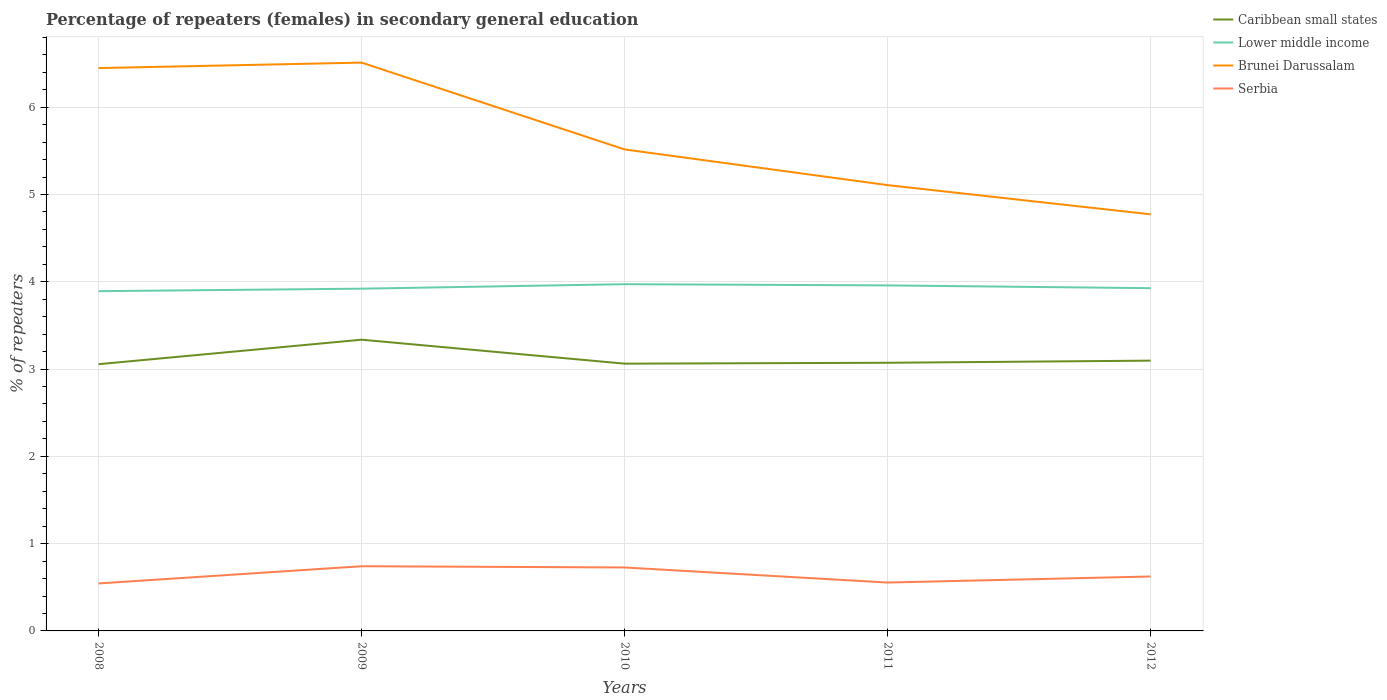How many different coloured lines are there?
Provide a succinct answer. 4. Does the line corresponding to Caribbean small states intersect with the line corresponding to Serbia?
Offer a terse response. No. Is the number of lines equal to the number of legend labels?
Offer a terse response. Yes. Across all years, what is the maximum percentage of female repeaters in Brunei Darussalam?
Provide a short and direct response. 4.77. What is the total percentage of female repeaters in Serbia in the graph?
Provide a short and direct response. 0.19. What is the difference between the highest and the second highest percentage of female repeaters in Serbia?
Provide a succinct answer. 0.2. What is the difference between the highest and the lowest percentage of female repeaters in Lower middle income?
Provide a short and direct response. 2. Is the percentage of female repeaters in Caribbean small states strictly greater than the percentage of female repeaters in Serbia over the years?
Offer a very short reply. No. How many lines are there?
Offer a very short reply. 4. How many years are there in the graph?
Offer a terse response. 5. Are the values on the major ticks of Y-axis written in scientific E-notation?
Give a very brief answer. No. Does the graph contain any zero values?
Offer a terse response. No. How are the legend labels stacked?
Make the answer very short. Vertical. What is the title of the graph?
Offer a very short reply. Percentage of repeaters (females) in secondary general education. What is the label or title of the Y-axis?
Provide a short and direct response. % of repeaters. What is the % of repeaters in Caribbean small states in 2008?
Offer a terse response. 3.06. What is the % of repeaters in Lower middle income in 2008?
Offer a terse response. 3.89. What is the % of repeaters in Brunei Darussalam in 2008?
Offer a terse response. 6.45. What is the % of repeaters of Serbia in 2008?
Offer a terse response. 0.54. What is the % of repeaters of Caribbean small states in 2009?
Offer a terse response. 3.34. What is the % of repeaters in Lower middle income in 2009?
Your answer should be compact. 3.92. What is the % of repeaters of Brunei Darussalam in 2009?
Provide a succinct answer. 6.51. What is the % of repeaters in Serbia in 2009?
Your answer should be very brief. 0.74. What is the % of repeaters of Caribbean small states in 2010?
Provide a succinct answer. 3.06. What is the % of repeaters of Lower middle income in 2010?
Offer a very short reply. 3.97. What is the % of repeaters of Brunei Darussalam in 2010?
Your answer should be compact. 5.52. What is the % of repeaters in Serbia in 2010?
Provide a succinct answer. 0.73. What is the % of repeaters of Caribbean small states in 2011?
Your answer should be very brief. 3.07. What is the % of repeaters of Lower middle income in 2011?
Your answer should be compact. 3.96. What is the % of repeaters of Brunei Darussalam in 2011?
Your response must be concise. 5.11. What is the % of repeaters of Serbia in 2011?
Keep it short and to the point. 0.55. What is the % of repeaters in Caribbean small states in 2012?
Provide a short and direct response. 3.1. What is the % of repeaters of Lower middle income in 2012?
Make the answer very short. 3.93. What is the % of repeaters of Brunei Darussalam in 2012?
Offer a very short reply. 4.77. What is the % of repeaters of Serbia in 2012?
Keep it short and to the point. 0.62. Across all years, what is the maximum % of repeaters of Caribbean small states?
Your answer should be very brief. 3.34. Across all years, what is the maximum % of repeaters in Lower middle income?
Offer a very short reply. 3.97. Across all years, what is the maximum % of repeaters in Brunei Darussalam?
Your answer should be compact. 6.51. Across all years, what is the maximum % of repeaters in Serbia?
Offer a terse response. 0.74. Across all years, what is the minimum % of repeaters of Caribbean small states?
Offer a very short reply. 3.06. Across all years, what is the minimum % of repeaters of Lower middle income?
Ensure brevity in your answer.  3.89. Across all years, what is the minimum % of repeaters of Brunei Darussalam?
Your answer should be compact. 4.77. Across all years, what is the minimum % of repeaters in Serbia?
Offer a terse response. 0.54. What is the total % of repeaters in Caribbean small states in the graph?
Offer a very short reply. 15.62. What is the total % of repeaters of Lower middle income in the graph?
Ensure brevity in your answer.  19.67. What is the total % of repeaters of Brunei Darussalam in the graph?
Make the answer very short. 28.35. What is the total % of repeaters of Serbia in the graph?
Make the answer very short. 3.19. What is the difference between the % of repeaters of Caribbean small states in 2008 and that in 2009?
Make the answer very short. -0.28. What is the difference between the % of repeaters of Lower middle income in 2008 and that in 2009?
Make the answer very short. -0.03. What is the difference between the % of repeaters of Brunei Darussalam in 2008 and that in 2009?
Keep it short and to the point. -0.06. What is the difference between the % of repeaters in Serbia in 2008 and that in 2009?
Give a very brief answer. -0.2. What is the difference between the % of repeaters of Caribbean small states in 2008 and that in 2010?
Offer a terse response. -0.01. What is the difference between the % of repeaters in Lower middle income in 2008 and that in 2010?
Your answer should be very brief. -0.08. What is the difference between the % of repeaters in Brunei Darussalam in 2008 and that in 2010?
Provide a succinct answer. 0.93. What is the difference between the % of repeaters of Serbia in 2008 and that in 2010?
Keep it short and to the point. -0.18. What is the difference between the % of repeaters in Caribbean small states in 2008 and that in 2011?
Your answer should be very brief. -0.02. What is the difference between the % of repeaters of Lower middle income in 2008 and that in 2011?
Ensure brevity in your answer.  -0.07. What is the difference between the % of repeaters in Brunei Darussalam in 2008 and that in 2011?
Provide a short and direct response. 1.34. What is the difference between the % of repeaters of Serbia in 2008 and that in 2011?
Your answer should be very brief. -0.01. What is the difference between the % of repeaters in Caribbean small states in 2008 and that in 2012?
Provide a succinct answer. -0.04. What is the difference between the % of repeaters of Lower middle income in 2008 and that in 2012?
Your response must be concise. -0.03. What is the difference between the % of repeaters in Brunei Darussalam in 2008 and that in 2012?
Give a very brief answer. 1.68. What is the difference between the % of repeaters in Serbia in 2008 and that in 2012?
Provide a short and direct response. -0.08. What is the difference between the % of repeaters in Caribbean small states in 2009 and that in 2010?
Your answer should be compact. 0.27. What is the difference between the % of repeaters in Lower middle income in 2009 and that in 2010?
Your answer should be compact. -0.05. What is the difference between the % of repeaters in Brunei Darussalam in 2009 and that in 2010?
Provide a succinct answer. 0.99. What is the difference between the % of repeaters of Serbia in 2009 and that in 2010?
Offer a very short reply. 0.01. What is the difference between the % of repeaters of Caribbean small states in 2009 and that in 2011?
Your answer should be very brief. 0.26. What is the difference between the % of repeaters in Lower middle income in 2009 and that in 2011?
Keep it short and to the point. -0.04. What is the difference between the % of repeaters of Brunei Darussalam in 2009 and that in 2011?
Make the answer very short. 1.4. What is the difference between the % of repeaters of Serbia in 2009 and that in 2011?
Offer a terse response. 0.19. What is the difference between the % of repeaters of Caribbean small states in 2009 and that in 2012?
Ensure brevity in your answer.  0.24. What is the difference between the % of repeaters of Lower middle income in 2009 and that in 2012?
Offer a very short reply. -0.01. What is the difference between the % of repeaters in Brunei Darussalam in 2009 and that in 2012?
Offer a very short reply. 1.74. What is the difference between the % of repeaters in Serbia in 2009 and that in 2012?
Your response must be concise. 0.12. What is the difference between the % of repeaters in Caribbean small states in 2010 and that in 2011?
Your answer should be very brief. -0.01. What is the difference between the % of repeaters in Lower middle income in 2010 and that in 2011?
Your answer should be very brief. 0.01. What is the difference between the % of repeaters in Brunei Darussalam in 2010 and that in 2011?
Your answer should be compact. 0.41. What is the difference between the % of repeaters of Serbia in 2010 and that in 2011?
Provide a short and direct response. 0.17. What is the difference between the % of repeaters in Caribbean small states in 2010 and that in 2012?
Your answer should be compact. -0.03. What is the difference between the % of repeaters in Lower middle income in 2010 and that in 2012?
Your response must be concise. 0.05. What is the difference between the % of repeaters in Brunei Darussalam in 2010 and that in 2012?
Your answer should be compact. 0.74. What is the difference between the % of repeaters of Serbia in 2010 and that in 2012?
Ensure brevity in your answer.  0.1. What is the difference between the % of repeaters of Caribbean small states in 2011 and that in 2012?
Provide a succinct answer. -0.02. What is the difference between the % of repeaters of Lower middle income in 2011 and that in 2012?
Your answer should be compact. 0.03. What is the difference between the % of repeaters of Brunei Darussalam in 2011 and that in 2012?
Give a very brief answer. 0.33. What is the difference between the % of repeaters in Serbia in 2011 and that in 2012?
Give a very brief answer. -0.07. What is the difference between the % of repeaters in Caribbean small states in 2008 and the % of repeaters in Lower middle income in 2009?
Your answer should be very brief. -0.87. What is the difference between the % of repeaters in Caribbean small states in 2008 and the % of repeaters in Brunei Darussalam in 2009?
Ensure brevity in your answer.  -3.45. What is the difference between the % of repeaters of Caribbean small states in 2008 and the % of repeaters of Serbia in 2009?
Offer a terse response. 2.31. What is the difference between the % of repeaters of Lower middle income in 2008 and the % of repeaters of Brunei Darussalam in 2009?
Provide a short and direct response. -2.62. What is the difference between the % of repeaters of Lower middle income in 2008 and the % of repeaters of Serbia in 2009?
Provide a succinct answer. 3.15. What is the difference between the % of repeaters of Brunei Darussalam in 2008 and the % of repeaters of Serbia in 2009?
Your answer should be compact. 5.71. What is the difference between the % of repeaters of Caribbean small states in 2008 and the % of repeaters of Lower middle income in 2010?
Keep it short and to the point. -0.92. What is the difference between the % of repeaters in Caribbean small states in 2008 and the % of repeaters in Brunei Darussalam in 2010?
Offer a terse response. -2.46. What is the difference between the % of repeaters of Caribbean small states in 2008 and the % of repeaters of Serbia in 2010?
Give a very brief answer. 2.33. What is the difference between the % of repeaters in Lower middle income in 2008 and the % of repeaters in Brunei Darussalam in 2010?
Offer a terse response. -1.62. What is the difference between the % of repeaters of Lower middle income in 2008 and the % of repeaters of Serbia in 2010?
Keep it short and to the point. 3.17. What is the difference between the % of repeaters in Brunei Darussalam in 2008 and the % of repeaters in Serbia in 2010?
Offer a terse response. 5.72. What is the difference between the % of repeaters of Caribbean small states in 2008 and the % of repeaters of Lower middle income in 2011?
Your response must be concise. -0.9. What is the difference between the % of repeaters of Caribbean small states in 2008 and the % of repeaters of Brunei Darussalam in 2011?
Your answer should be compact. -2.05. What is the difference between the % of repeaters in Caribbean small states in 2008 and the % of repeaters in Serbia in 2011?
Ensure brevity in your answer.  2.5. What is the difference between the % of repeaters of Lower middle income in 2008 and the % of repeaters of Brunei Darussalam in 2011?
Keep it short and to the point. -1.21. What is the difference between the % of repeaters of Lower middle income in 2008 and the % of repeaters of Serbia in 2011?
Offer a very short reply. 3.34. What is the difference between the % of repeaters of Brunei Darussalam in 2008 and the % of repeaters of Serbia in 2011?
Provide a short and direct response. 5.89. What is the difference between the % of repeaters of Caribbean small states in 2008 and the % of repeaters of Lower middle income in 2012?
Your response must be concise. -0.87. What is the difference between the % of repeaters in Caribbean small states in 2008 and the % of repeaters in Brunei Darussalam in 2012?
Ensure brevity in your answer.  -1.72. What is the difference between the % of repeaters of Caribbean small states in 2008 and the % of repeaters of Serbia in 2012?
Keep it short and to the point. 2.43. What is the difference between the % of repeaters of Lower middle income in 2008 and the % of repeaters of Brunei Darussalam in 2012?
Provide a short and direct response. -0.88. What is the difference between the % of repeaters in Lower middle income in 2008 and the % of repeaters in Serbia in 2012?
Your answer should be compact. 3.27. What is the difference between the % of repeaters of Brunei Darussalam in 2008 and the % of repeaters of Serbia in 2012?
Provide a short and direct response. 5.82. What is the difference between the % of repeaters in Caribbean small states in 2009 and the % of repeaters in Lower middle income in 2010?
Make the answer very short. -0.64. What is the difference between the % of repeaters of Caribbean small states in 2009 and the % of repeaters of Brunei Darussalam in 2010?
Offer a very short reply. -2.18. What is the difference between the % of repeaters of Caribbean small states in 2009 and the % of repeaters of Serbia in 2010?
Give a very brief answer. 2.61. What is the difference between the % of repeaters of Lower middle income in 2009 and the % of repeaters of Brunei Darussalam in 2010?
Ensure brevity in your answer.  -1.6. What is the difference between the % of repeaters in Lower middle income in 2009 and the % of repeaters in Serbia in 2010?
Make the answer very short. 3.19. What is the difference between the % of repeaters of Brunei Darussalam in 2009 and the % of repeaters of Serbia in 2010?
Your answer should be compact. 5.78. What is the difference between the % of repeaters of Caribbean small states in 2009 and the % of repeaters of Lower middle income in 2011?
Your answer should be very brief. -0.62. What is the difference between the % of repeaters of Caribbean small states in 2009 and the % of repeaters of Brunei Darussalam in 2011?
Offer a very short reply. -1.77. What is the difference between the % of repeaters of Caribbean small states in 2009 and the % of repeaters of Serbia in 2011?
Your answer should be very brief. 2.78. What is the difference between the % of repeaters in Lower middle income in 2009 and the % of repeaters in Brunei Darussalam in 2011?
Ensure brevity in your answer.  -1.19. What is the difference between the % of repeaters of Lower middle income in 2009 and the % of repeaters of Serbia in 2011?
Offer a very short reply. 3.37. What is the difference between the % of repeaters in Brunei Darussalam in 2009 and the % of repeaters in Serbia in 2011?
Give a very brief answer. 5.96. What is the difference between the % of repeaters in Caribbean small states in 2009 and the % of repeaters in Lower middle income in 2012?
Provide a succinct answer. -0.59. What is the difference between the % of repeaters of Caribbean small states in 2009 and the % of repeaters of Brunei Darussalam in 2012?
Keep it short and to the point. -1.44. What is the difference between the % of repeaters of Caribbean small states in 2009 and the % of repeaters of Serbia in 2012?
Provide a short and direct response. 2.71. What is the difference between the % of repeaters of Lower middle income in 2009 and the % of repeaters of Brunei Darussalam in 2012?
Give a very brief answer. -0.85. What is the difference between the % of repeaters in Lower middle income in 2009 and the % of repeaters in Serbia in 2012?
Offer a very short reply. 3.3. What is the difference between the % of repeaters in Brunei Darussalam in 2009 and the % of repeaters in Serbia in 2012?
Offer a very short reply. 5.89. What is the difference between the % of repeaters in Caribbean small states in 2010 and the % of repeaters in Lower middle income in 2011?
Offer a very short reply. -0.9. What is the difference between the % of repeaters of Caribbean small states in 2010 and the % of repeaters of Brunei Darussalam in 2011?
Your answer should be very brief. -2.05. What is the difference between the % of repeaters in Caribbean small states in 2010 and the % of repeaters in Serbia in 2011?
Your answer should be compact. 2.51. What is the difference between the % of repeaters in Lower middle income in 2010 and the % of repeaters in Brunei Darussalam in 2011?
Your answer should be very brief. -1.13. What is the difference between the % of repeaters in Lower middle income in 2010 and the % of repeaters in Serbia in 2011?
Your answer should be compact. 3.42. What is the difference between the % of repeaters of Brunei Darussalam in 2010 and the % of repeaters of Serbia in 2011?
Your answer should be very brief. 4.96. What is the difference between the % of repeaters of Caribbean small states in 2010 and the % of repeaters of Lower middle income in 2012?
Your response must be concise. -0.86. What is the difference between the % of repeaters in Caribbean small states in 2010 and the % of repeaters in Brunei Darussalam in 2012?
Offer a terse response. -1.71. What is the difference between the % of repeaters in Caribbean small states in 2010 and the % of repeaters in Serbia in 2012?
Provide a succinct answer. 2.44. What is the difference between the % of repeaters in Lower middle income in 2010 and the % of repeaters in Brunei Darussalam in 2012?
Ensure brevity in your answer.  -0.8. What is the difference between the % of repeaters in Lower middle income in 2010 and the % of repeaters in Serbia in 2012?
Make the answer very short. 3.35. What is the difference between the % of repeaters in Brunei Darussalam in 2010 and the % of repeaters in Serbia in 2012?
Offer a very short reply. 4.89. What is the difference between the % of repeaters in Caribbean small states in 2011 and the % of repeaters in Lower middle income in 2012?
Keep it short and to the point. -0.85. What is the difference between the % of repeaters in Caribbean small states in 2011 and the % of repeaters in Brunei Darussalam in 2012?
Offer a terse response. -1.7. What is the difference between the % of repeaters of Caribbean small states in 2011 and the % of repeaters of Serbia in 2012?
Your response must be concise. 2.45. What is the difference between the % of repeaters of Lower middle income in 2011 and the % of repeaters of Brunei Darussalam in 2012?
Your response must be concise. -0.81. What is the difference between the % of repeaters in Lower middle income in 2011 and the % of repeaters in Serbia in 2012?
Ensure brevity in your answer.  3.33. What is the difference between the % of repeaters of Brunei Darussalam in 2011 and the % of repeaters of Serbia in 2012?
Offer a terse response. 4.48. What is the average % of repeaters in Caribbean small states per year?
Your answer should be very brief. 3.12. What is the average % of repeaters of Lower middle income per year?
Your response must be concise. 3.93. What is the average % of repeaters of Brunei Darussalam per year?
Ensure brevity in your answer.  5.67. What is the average % of repeaters in Serbia per year?
Your response must be concise. 0.64. In the year 2008, what is the difference between the % of repeaters of Caribbean small states and % of repeaters of Lower middle income?
Keep it short and to the point. -0.84. In the year 2008, what is the difference between the % of repeaters in Caribbean small states and % of repeaters in Brunei Darussalam?
Your answer should be very brief. -3.39. In the year 2008, what is the difference between the % of repeaters in Caribbean small states and % of repeaters in Serbia?
Your response must be concise. 2.51. In the year 2008, what is the difference between the % of repeaters of Lower middle income and % of repeaters of Brunei Darussalam?
Provide a succinct answer. -2.56. In the year 2008, what is the difference between the % of repeaters in Lower middle income and % of repeaters in Serbia?
Offer a very short reply. 3.35. In the year 2008, what is the difference between the % of repeaters in Brunei Darussalam and % of repeaters in Serbia?
Provide a succinct answer. 5.9. In the year 2009, what is the difference between the % of repeaters of Caribbean small states and % of repeaters of Lower middle income?
Give a very brief answer. -0.58. In the year 2009, what is the difference between the % of repeaters in Caribbean small states and % of repeaters in Brunei Darussalam?
Give a very brief answer. -3.17. In the year 2009, what is the difference between the % of repeaters in Caribbean small states and % of repeaters in Serbia?
Your answer should be very brief. 2.6. In the year 2009, what is the difference between the % of repeaters of Lower middle income and % of repeaters of Brunei Darussalam?
Offer a very short reply. -2.59. In the year 2009, what is the difference between the % of repeaters of Lower middle income and % of repeaters of Serbia?
Your answer should be very brief. 3.18. In the year 2009, what is the difference between the % of repeaters of Brunei Darussalam and % of repeaters of Serbia?
Give a very brief answer. 5.77. In the year 2010, what is the difference between the % of repeaters in Caribbean small states and % of repeaters in Lower middle income?
Keep it short and to the point. -0.91. In the year 2010, what is the difference between the % of repeaters in Caribbean small states and % of repeaters in Brunei Darussalam?
Your answer should be very brief. -2.45. In the year 2010, what is the difference between the % of repeaters of Caribbean small states and % of repeaters of Serbia?
Ensure brevity in your answer.  2.33. In the year 2010, what is the difference between the % of repeaters in Lower middle income and % of repeaters in Brunei Darussalam?
Your answer should be compact. -1.54. In the year 2010, what is the difference between the % of repeaters in Lower middle income and % of repeaters in Serbia?
Offer a terse response. 3.25. In the year 2010, what is the difference between the % of repeaters in Brunei Darussalam and % of repeaters in Serbia?
Your answer should be very brief. 4.79. In the year 2011, what is the difference between the % of repeaters of Caribbean small states and % of repeaters of Lower middle income?
Keep it short and to the point. -0.89. In the year 2011, what is the difference between the % of repeaters in Caribbean small states and % of repeaters in Brunei Darussalam?
Provide a short and direct response. -2.04. In the year 2011, what is the difference between the % of repeaters of Caribbean small states and % of repeaters of Serbia?
Give a very brief answer. 2.52. In the year 2011, what is the difference between the % of repeaters in Lower middle income and % of repeaters in Brunei Darussalam?
Your answer should be compact. -1.15. In the year 2011, what is the difference between the % of repeaters in Lower middle income and % of repeaters in Serbia?
Offer a terse response. 3.4. In the year 2011, what is the difference between the % of repeaters in Brunei Darussalam and % of repeaters in Serbia?
Offer a terse response. 4.55. In the year 2012, what is the difference between the % of repeaters of Caribbean small states and % of repeaters of Lower middle income?
Offer a terse response. -0.83. In the year 2012, what is the difference between the % of repeaters in Caribbean small states and % of repeaters in Brunei Darussalam?
Keep it short and to the point. -1.68. In the year 2012, what is the difference between the % of repeaters of Caribbean small states and % of repeaters of Serbia?
Offer a very short reply. 2.47. In the year 2012, what is the difference between the % of repeaters of Lower middle income and % of repeaters of Brunei Darussalam?
Offer a very short reply. -0.85. In the year 2012, what is the difference between the % of repeaters in Lower middle income and % of repeaters in Serbia?
Keep it short and to the point. 3.3. In the year 2012, what is the difference between the % of repeaters in Brunei Darussalam and % of repeaters in Serbia?
Provide a short and direct response. 4.15. What is the ratio of the % of repeaters of Caribbean small states in 2008 to that in 2009?
Your answer should be very brief. 0.92. What is the ratio of the % of repeaters in Lower middle income in 2008 to that in 2009?
Ensure brevity in your answer.  0.99. What is the ratio of the % of repeaters of Brunei Darussalam in 2008 to that in 2009?
Your answer should be very brief. 0.99. What is the ratio of the % of repeaters in Serbia in 2008 to that in 2009?
Offer a very short reply. 0.73. What is the ratio of the % of repeaters in Caribbean small states in 2008 to that in 2010?
Your response must be concise. 1. What is the ratio of the % of repeaters in Lower middle income in 2008 to that in 2010?
Your answer should be compact. 0.98. What is the ratio of the % of repeaters in Brunei Darussalam in 2008 to that in 2010?
Offer a very short reply. 1.17. What is the ratio of the % of repeaters of Serbia in 2008 to that in 2010?
Make the answer very short. 0.75. What is the ratio of the % of repeaters of Lower middle income in 2008 to that in 2011?
Offer a terse response. 0.98. What is the ratio of the % of repeaters of Brunei Darussalam in 2008 to that in 2011?
Offer a very short reply. 1.26. What is the ratio of the % of repeaters of Serbia in 2008 to that in 2011?
Keep it short and to the point. 0.98. What is the ratio of the % of repeaters in Caribbean small states in 2008 to that in 2012?
Give a very brief answer. 0.99. What is the ratio of the % of repeaters in Lower middle income in 2008 to that in 2012?
Your answer should be very brief. 0.99. What is the ratio of the % of repeaters in Brunei Darussalam in 2008 to that in 2012?
Keep it short and to the point. 1.35. What is the ratio of the % of repeaters of Serbia in 2008 to that in 2012?
Your response must be concise. 0.87. What is the ratio of the % of repeaters in Caribbean small states in 2009 to that in 2010?
Your answer should be compact. 1.09. What is the ratio of the % of repeaters of Lower middle income in 2009 to that in 2010?
Give a very brief answer. 0.99. What is the ratio of the % of repeaters of Brunei Darussalam in 2009 to that in 2010?
Ensure brevity in your answer.  1.18. What is the ratio of the % of repeaters in Serbia in 2009 to that in 2010?
Provide a short and direct response. 1.02. What is the ratio of the % of repeaters of Caribbean small states in 2009 to that in 2011?
Give a very brief answer. 1.09. What is the ratio of the % of repeaters in Lower middle income in 2009 to that in 2011?
Your response must be concise. 0.99. What is the ratio of the % of repeaters in Brunei Darussalam in 2009 to that in 2011?
Your response must be concise. 1.27. What is the ratio of the % of repeaters of Serbia in 2009 to that in 2011?
Offer a terse response. 1.34. What is the ratio of the % of repeaters of Caribbean small states in 2009 to that in 2012?
Offer a terse response. 1.08. What is the ratio of the % of repeaters in Brunei Darussalam in 2009 to that in 2012?
Give a very brief answer. 1.36. What is the ratio of the % of repeaters of Serbia in 2009 to that in 2012?
Give a very brief answer. 1.19. What is the ratio of the % of repeaters in Caribbean small states in 2010 to that in 2011?
Your response must be concise. 1. What is the ratio of the % of repeaters in Brunei Darussalam in 2010 to that in 2011?
Give a very brief answer. 1.08. What is the ratio of the % of repeaters in Serbia in 2010 to that in 2011?
Your response must be concise. 1.31. What is the ratio of the % of repeaters in Caribbean small states in 2010 to that in 2012?
Offer a terse response. 0.99. What is the ratio of the % of repeaters of Lower middle income in 2010 to that in 2012?
Keep it short and to the point. 1.01. What is the ratio of the % of repeaters in Brunei Darussalam in 2010 to that in 2012?
Offer a terse response. 1.16. What is the ratio of the % of repeaters of Serbia in 2010 to that in 2012?
Your answer should be very brief. 1.17. What is the ratio of the % of repeaters in Caribbean small states in 2011 to that in 2012?
Offer a very short reply. 0.99. What is the ratio of the % of repeaters of Brunei Darussalam in 2011 to that in 2012?
Offer a very short reply. 1.07. What is the difference between the highest and the second highest % of repeaters in Caribbean small states?
Your answer should be compact. 0.24. What is the difference between the highest and the second highest % of repeaters of Lower middle income?
Keep it short and to the point. 0.01. What is the difference between the highest and the second highest % of repeaters in Brunei Darussalam?
Offer a very short reply. 0.06. What is the difference between the highest and the second highest % of repeaters of Serbia?
Offer a very short reply. 0.01. What is the difference between the highest and the lowest % of repeaters of Caribbean small states?
Your response must be concise. 0.28. What is the difference between the highest and the lowest % of repeaters in Lower middle income?
Ensure brevity in your answer.  0.08. What is the difference between the highest and the lowest % of repeaters of Brunei Darussalam?
Give a very brief answer. 1.74. What is the difference between the highest and the lowest % of repeaters in Serbia?
Keep it short and to the point. 0.2. 